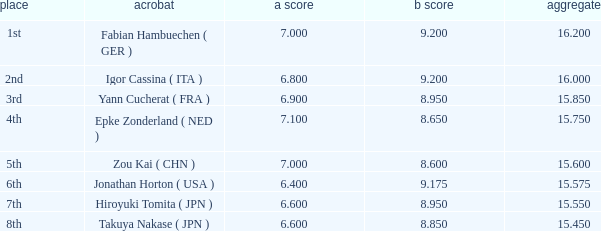Which gymnast had a b score of 8.95 and an a score less than 6.9 Hiroyuki Tomita ( JPN ). 